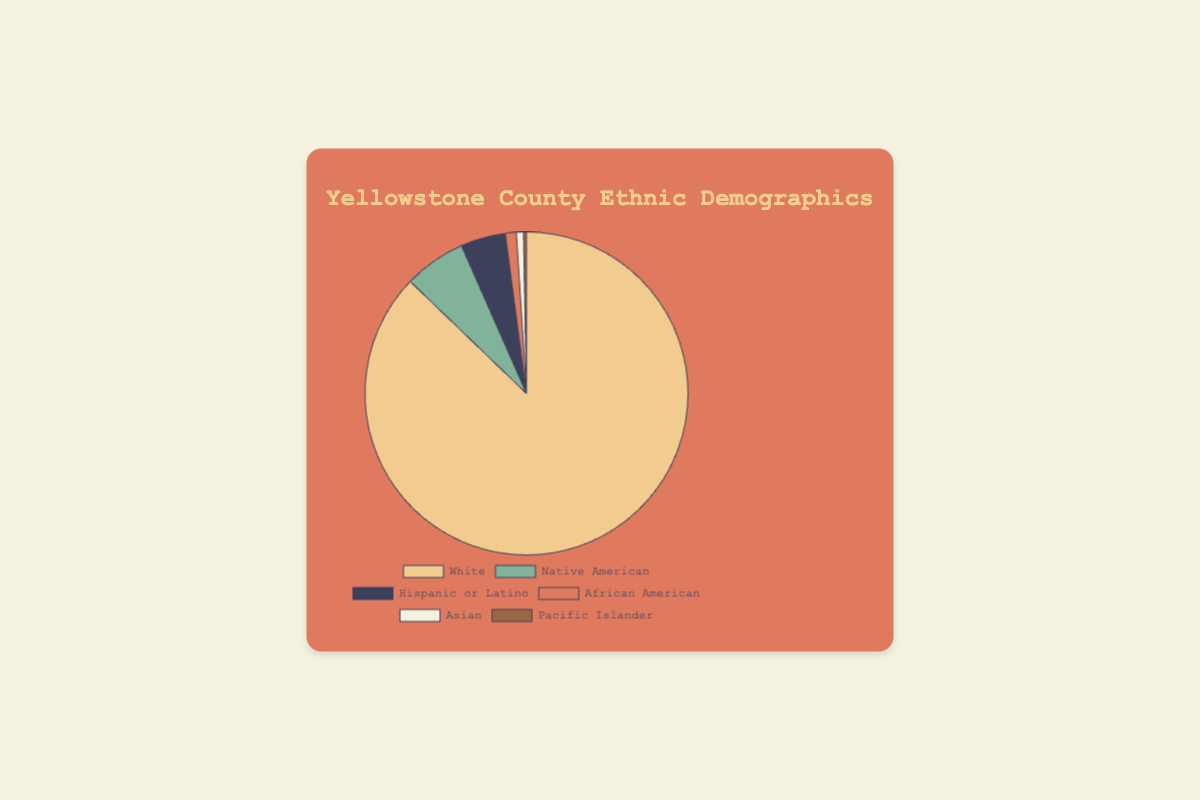What percentage of the population in Yellowstone County identifies as White? From the pie chart, the labeled section for "White" shows a percentage of 87.2%.
Answer: 87.2% What is the combined percentage of Native American and Hispanic or Latino populations in Yellowstone County? According to the pie chart, Native American makes up 6.2% and Hispanic or Latino makes up 4.5%, so their combined percentage is 6.2% + 4.5% = 10.7%.
Answer: 10.7% Which ethnic group has the smallest representation in Yellowstone County? From the pie chart, "Pacific Islander" has the smallest percentage at 0.3%.
Answer: Pacific Islander How much larger is the percentage of White residents compared to Hispanic or Latino residents? "White" residents make up 87.2% of the population while "Hispanic or Latino" residents make up 4.5%. The difference is 87.2% - 4.5% = 82.7%.
Answer: 82.7% What is the average percentage of the population for the African American, Asian, and Pacific Islander groups? The percentages for these groups are African American: 1.1%, Asian: 0.7%, and Pacific Islander: 0.3%. The average is (1.1% + 0.7% + 0.3%) / 3 = 0.7%.
Answer: 0.7% How many ethnic groups in Yellowstone County have a population percentage of less than 5%? According to the chart, Native American (6.2%) exceeds 5%, while Hispanic or Latino (4.5%), African American (1.1%), Asian (0.7%), and Pacific Islander (0.3%) are below 5%. Thus, four groups have percentages less than 5%.
Answer: 4 Which group has a larger percentage, Native American or Hispanic or Latino, and by how much? Native American residents make up 6.2%, and Hispanic or Latino residents make up 4.5%. The difference is 6.2% - 4.5% = 1.7%.
Answer: Native American by 1.7% What are the colors used to represent the White and Native American populations in the pie chart? Observing the chart, the "White" section is represented by a light yellow color and the "Native American" section is represented by a green color.
Answer: Light yellow and green 